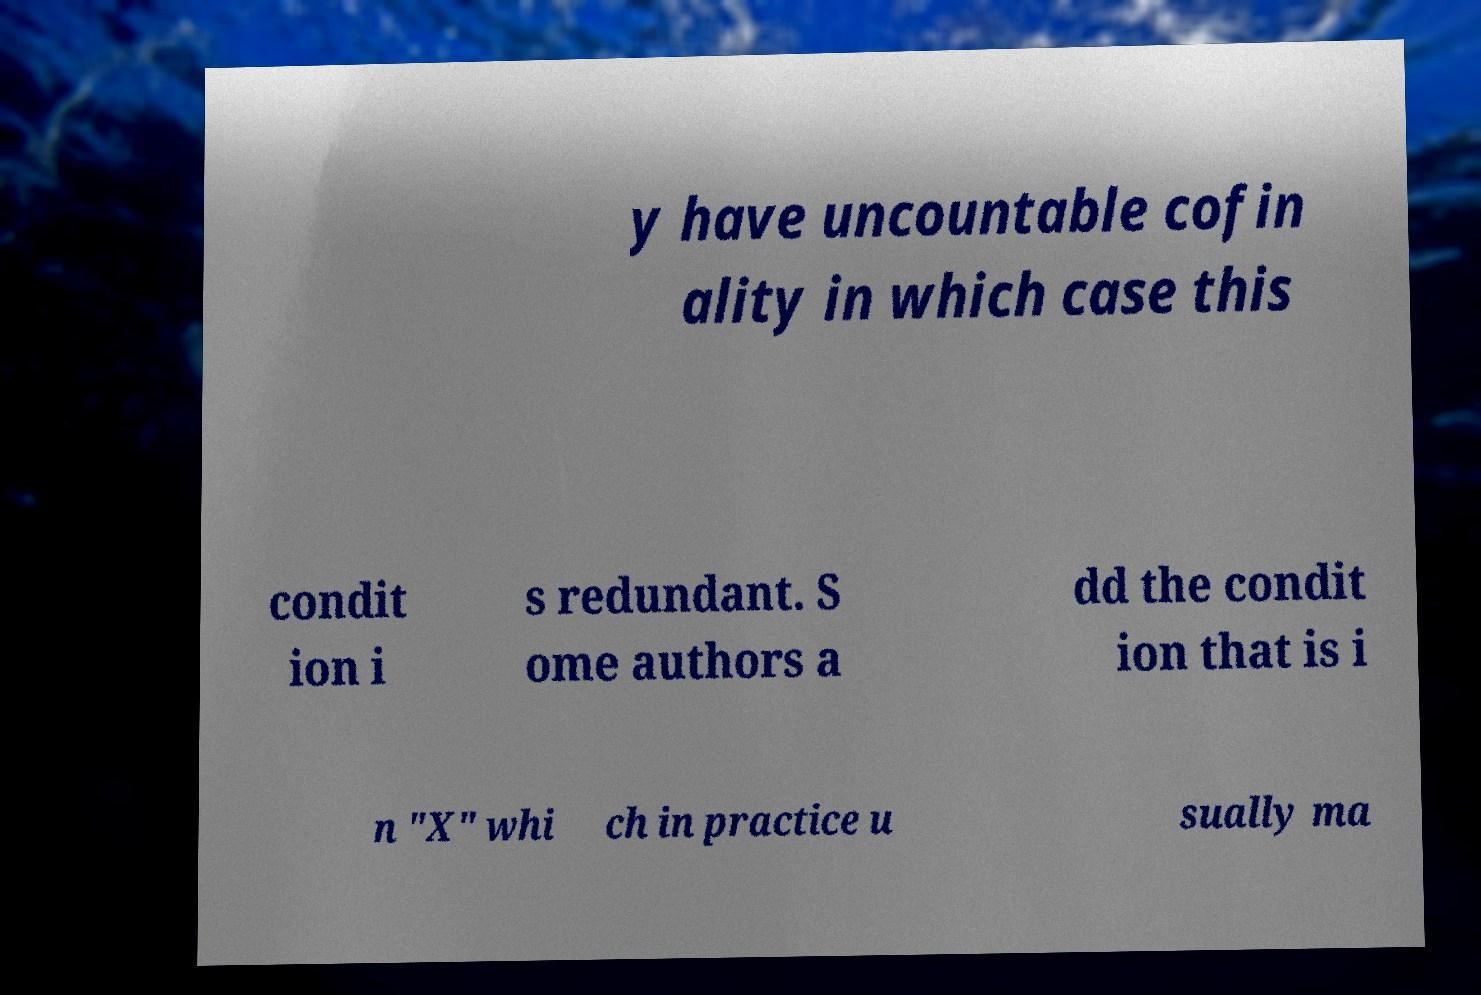Could you extract and type out the text from this image? y have uncountable cofin ality in which case this condit ion i s redundant. S ome authors a dd the condit ion that is i n "X" whi ch in practice u sually ma 